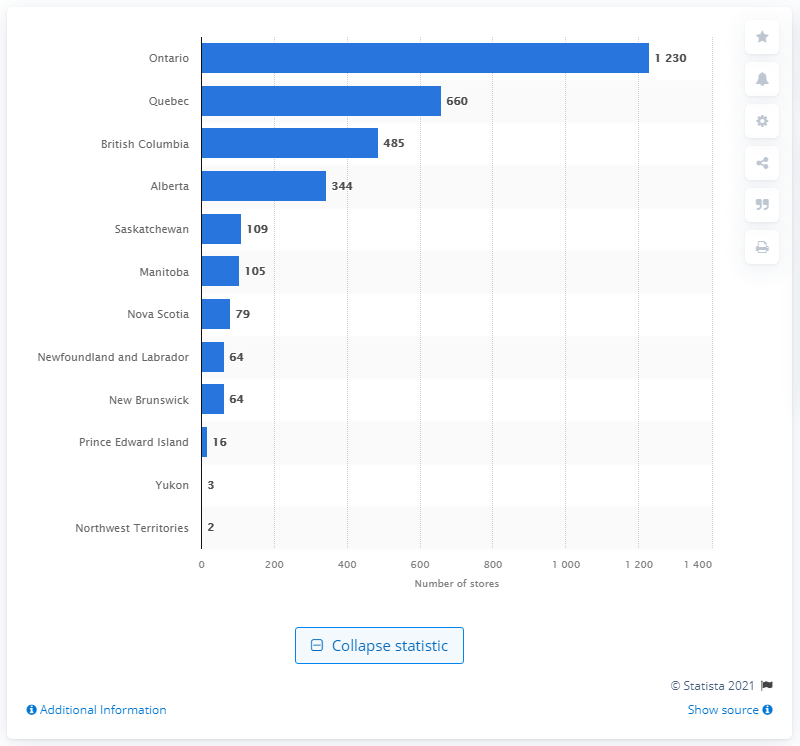Indicate a few pertinent items in this graphic. There were 660 furniture stores in Quebec in December of 2020. 